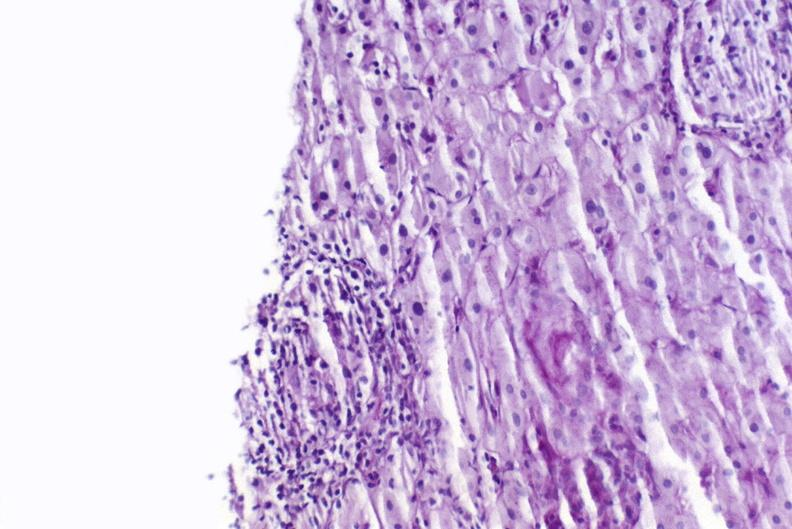s hepatobiliary present?
Answer the question using a single word or phrase. Yes 